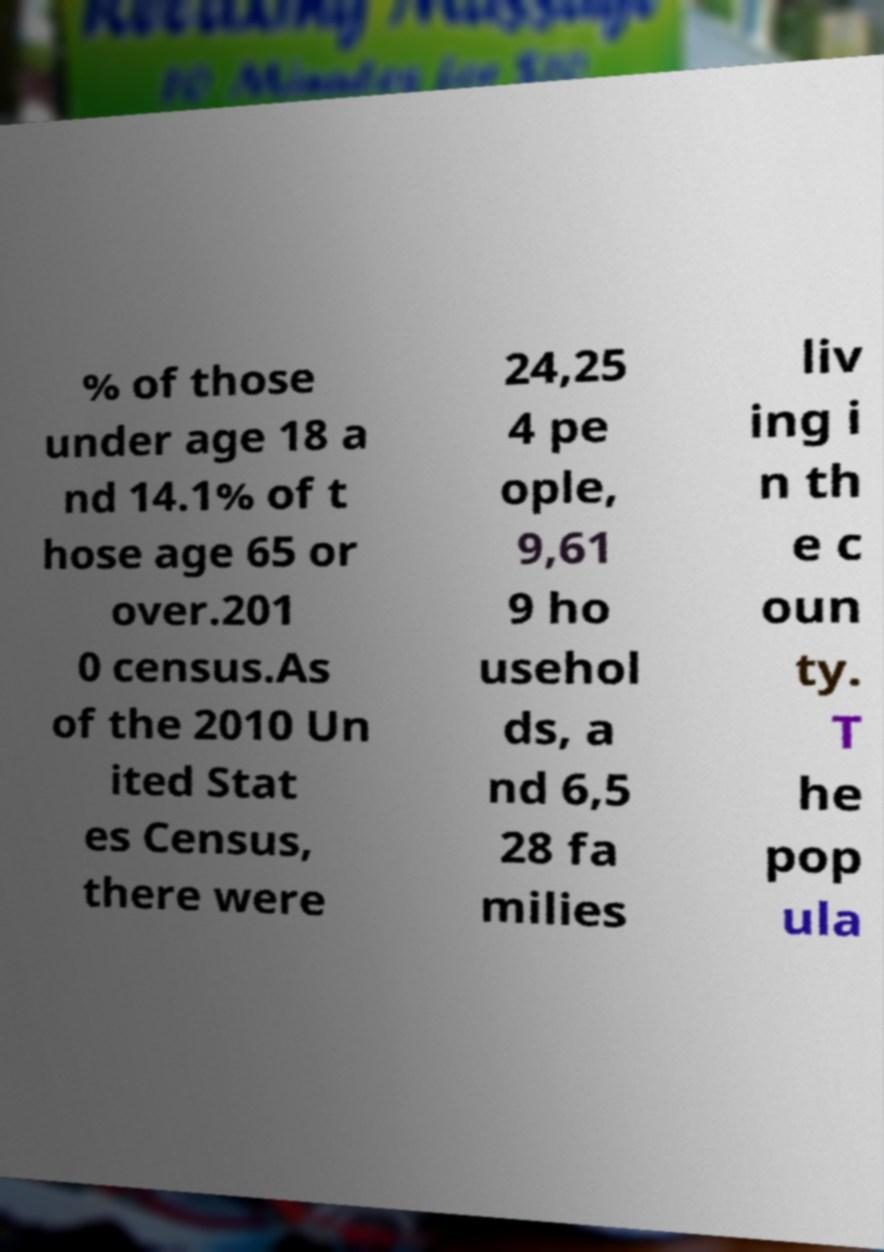Could you assist in decoding the text presented in this image and type it out clearly? % of those under age 18 a nd 14.1% of t hose age 65 or over.201 0 census.As of the 2010 Un ited Stat es Census, there were 24,25 4 pe ople, 9,61 9 ho usehol ds, a nd 6,5 28 fa milies liv ing i n th e c oun ty. T he pop ula 